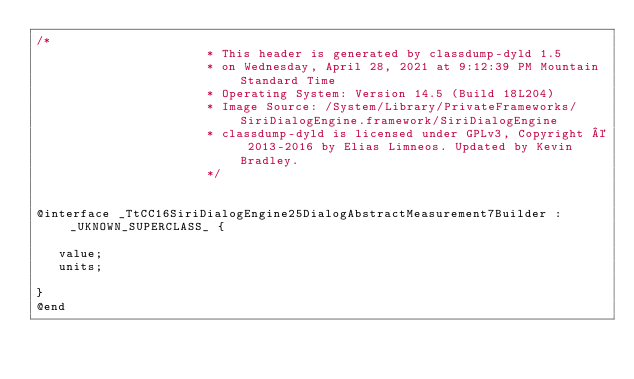<code> <loc_0><loc_0><loc_500><loc_500><_C_>/*
                       * This header is generated by classdump-dyld 1.5
                       * on Wednesday, April 28, 2021 at 9:12:39 PM Mountain Standard Time
                       * Operating System: Version 14.5 (Build 18L204)
                       * Image Source: /System/Library/PrivateFrameworks/SiriDialogEngine.framework/SiriDialogEngine
                       * classdump-dyld is licensed under GPLv3, Copyright © 2013-2016 by Elias Limneos. Updated by Kevin Bradley.
                       */


@interface _TtCC16SiriDialogEngine25DialogAbstractMeasurement7Builder : _UKNOWN_SUPERCLASS_ {

	 value;
	 units;

}
@end

</code> 